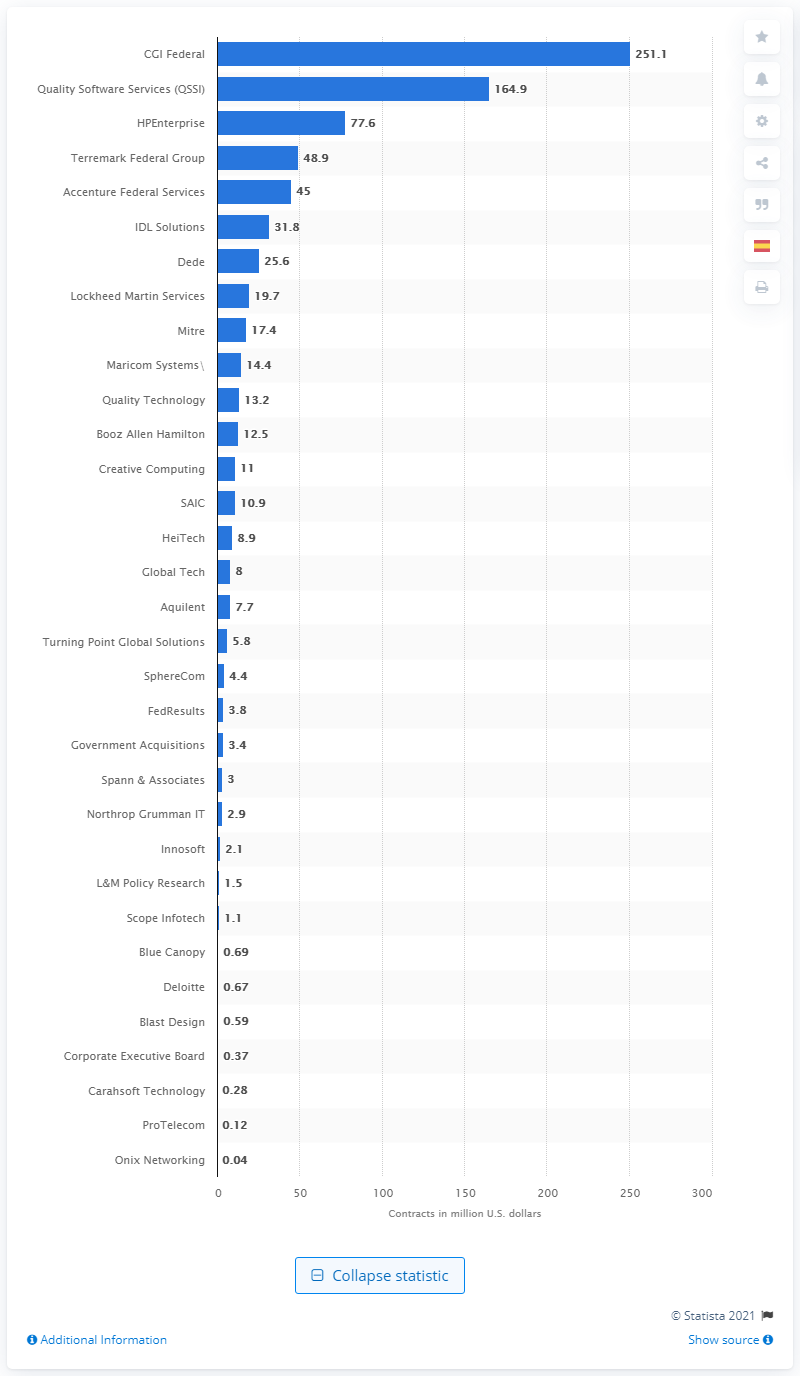Point out several critical features in this image. The contract for IDL Solutions was worth 31.8 million dollars. 